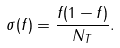<formula> <loc_0><loc_0><loc_500><loc_500>\sigma ( f ) = \frac { f ( 1 - f ) } { N _ { T } } .</formula> 